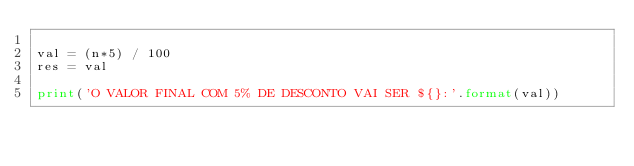Convert code to text. <code><loc_0><loc_0><loc_500><loc_500><_Python_>
val = (n*5) / 100
res = val

print('O VALOR FINAL COM 5% DE DESCONTO VAI SER ${}:'.format(val))
</code> 